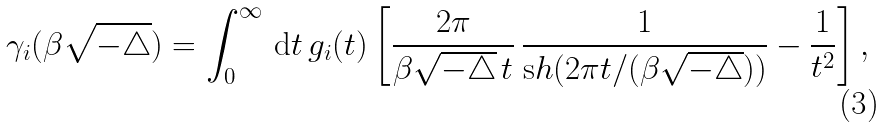<formula> <loc_0><loc_0><loc_500><loc_500>\gamma _ { i } ( \beta \sqrt { - \triangle } ) = \int _ { 0 } ^ { \infty } \, { \mathrm d } t \, g _ { i } ( t ) \left [ \frac { 2 \pi } { \beta { \sqrt { - \triangle } } \, t } \, \frac { 1 } { { \mathrm s h } ( 2 \pi t / ( \beta { \sqrt { - \triangle } } ) ) } - \frac { 1 } { t ^ { 2 } } \right ] ,</formula> 